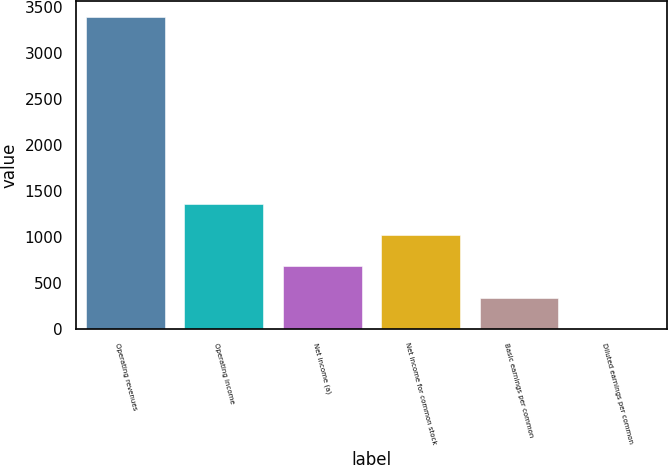Convert chart. <chart><loc_0><loc_0><loc_500><loc_500><bar_chart><fcel>Operating revenues<fcel>Operating income<fcel>Net income (a)<fcel>Net income for common stock<fcel>Basic earnings per common<fcel>Diluted earnings per common<nl><fcel>3390<fcel>1356.88<fcel>679.18<fcel>1018.03<fcel>340.33<fcel>1.48<nl></chart> 